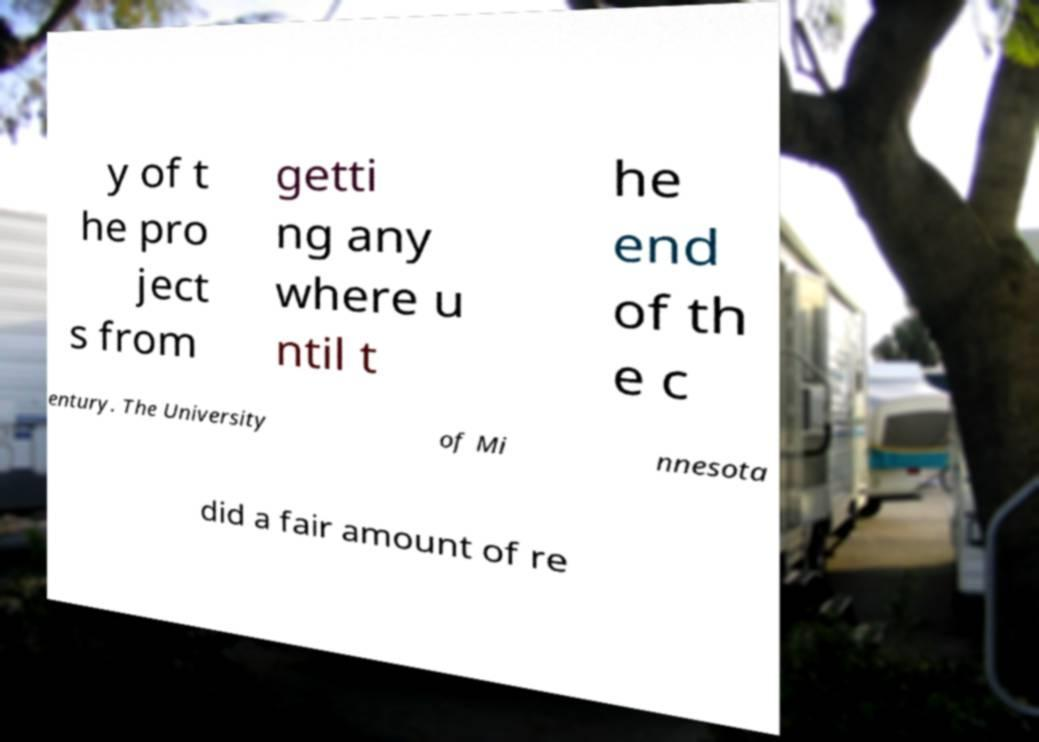Could you assist in decoding the text presented in this image and type it out clearly? y of t he pro ject s from getti ng any where u ntil t he end of th e c entury. The University of Mi nnesota did a fair amount of re 